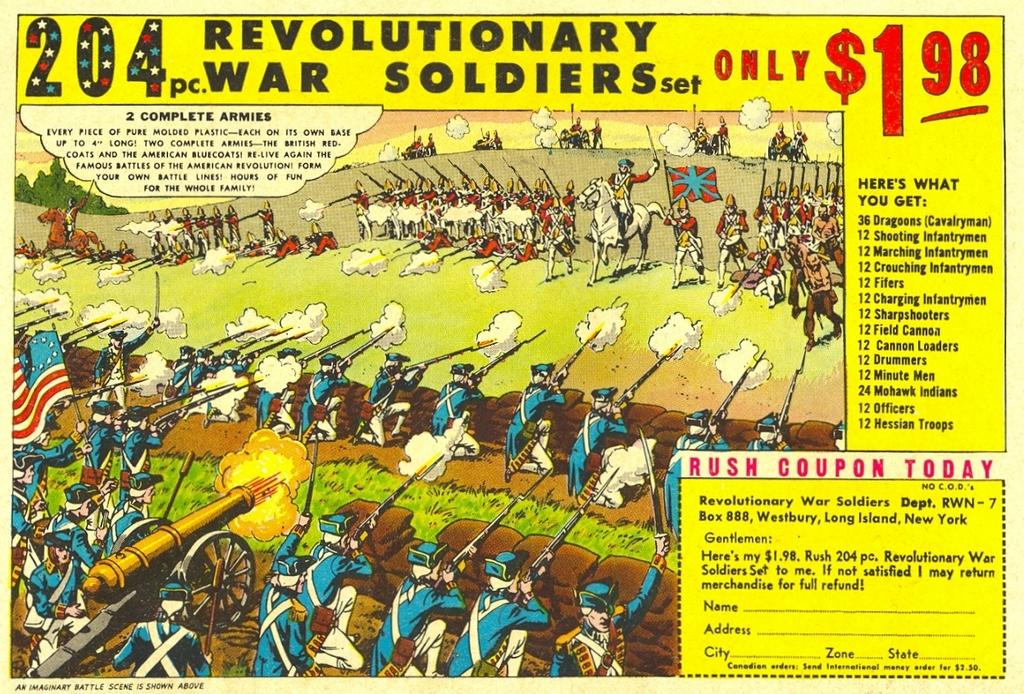How many pieces is this set?
Provide a short and direct response. 204. Whta´s the price of this set?
Provide a short and direct response. $1.98. 